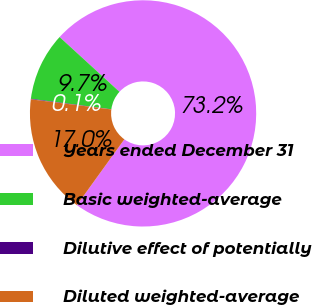Convert chart. <chart><loc_0><loc_0><loc_500><loc_500><pie_chart><fcel>Years ended December 31<fcel>Basic weighted-average<fcel>Dilutive effect of potentially<fcel>Diluted weighted-average<nl><fcel>73.16%<fcel>9.73%<fcel>0.08%<fcel>17.04%<nl></chart> 